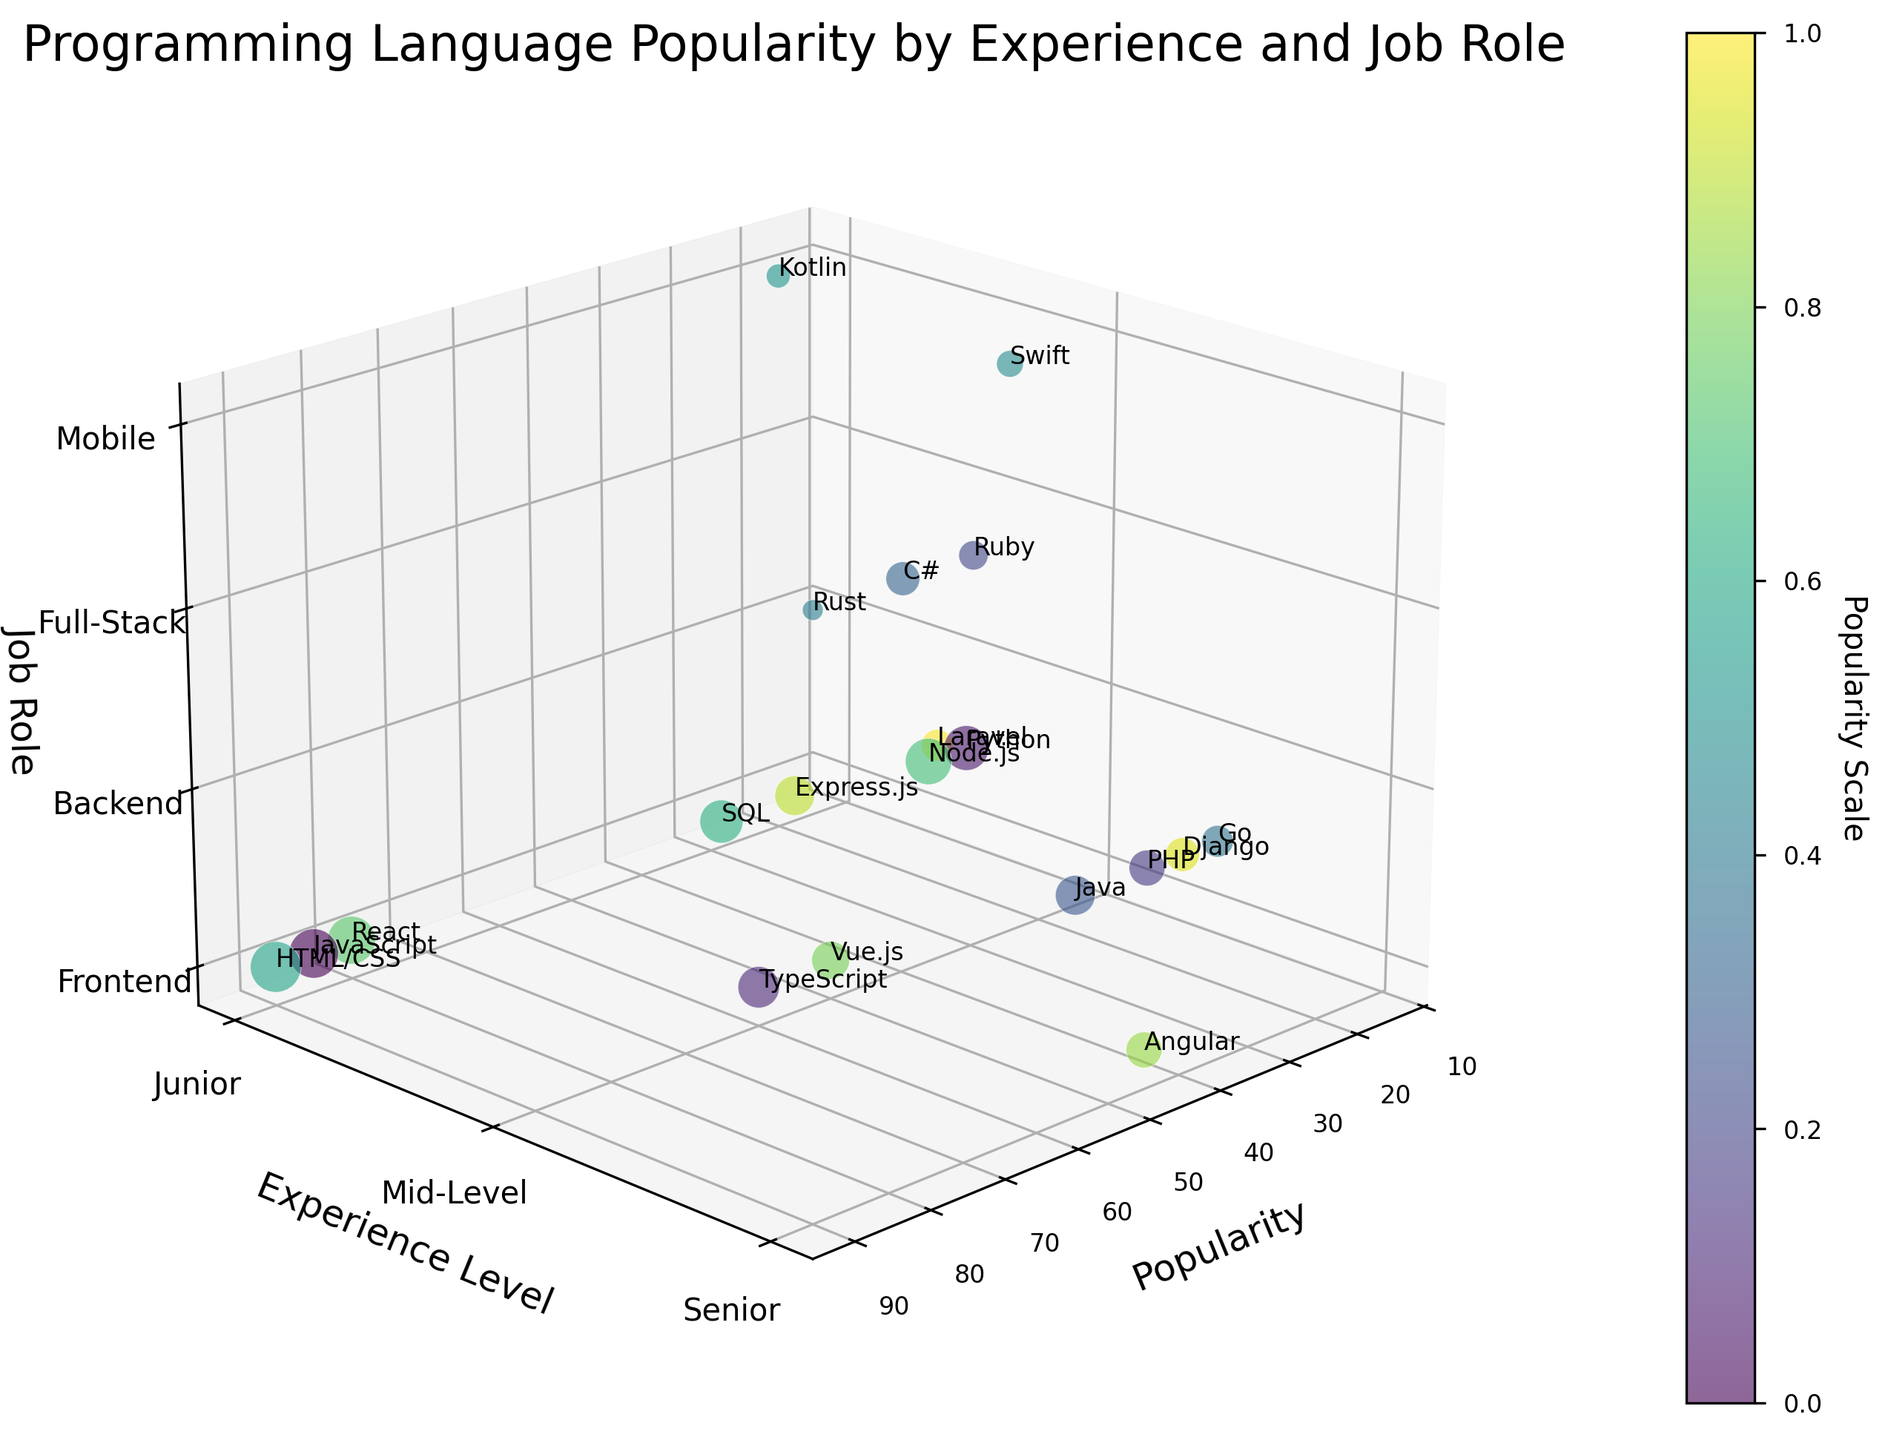What does the figure's title indicate? The figure's title provides a concise summary of the chart's content, showing that it depicts programming language popularity among web developers segmented by experience level and job role. It sets the context for interpreting the plotted data.
Answer: Programming Language Popularity by Experience and Job Role How are the experience levels represented along the y-axis? The y-axis uses labels to indicate three distinct experience levels: "Junior," "Mid-Level," and "Senior." These labels correspond to specific numerical values used in plotting the data on the y-axis.
Answer: Junior, Mid-Level, Senior Which job role has the highest popularity score, and for which language? Analyzing the z-axis for job roles and the x-axis for popularity scores, we see that Frontend developers using HTML/CSS have the highest popularity score. This is indicated by a bubble with a high value on the popularity axis.
Answer: Frontend, HTML/CSS What can you say about the popularity of JavaScript among Junior web developers? By locating the bubble for JavaScript in the 3D space, we observe it positioned at the Junior experience level and Frontend job role, with a popularity score of 85. This indicates JavaScript is very popular among Junior Frontend developers.
Answer: Very popular (85) Which programming languages are used by Mid-Level Mobile developers? Observing the z-axis for the Mobile job role and the y-axis for Mid-Level experience, we can identify Swift as the programming language represented by bubbles at this intersection.
Answer: Swift Compare the popularity of Python among Senior Full-Stack developers to that of Node.js among the same group. Which one is more popular? Both bubbles are located at Senior experience level and Full-Stack job role on the 3D chart. Python's bubble shows a popularity of 70, whereas Node.js' bubble displays a higher popularity of 75.
Answer: Node.js is more popular (75) Which programming language has the lowest popularity score, and in what context (experience level and job role)? The bubble positioned at the lowest value on the popularity axis corresponds to Rust, which is at the Junior level and Backend job role, indicating it's the least popular among studied languages.
Answer: Rust, Junior, Backend Identify the programming languages preferred by Senior Backend developers. By isolating the Senior experience level on the y-axis and Backend role on the z-axis, we find bubbles for PHP (45), Java (55), Go (35), and Django (40). These languages are preferred by Senior Backend developers.
Answer: PHP, Java, Go, Django What is the difference in popularity between React and Vue.js among Junior Frontend developers? Locate the bubbles for React and Vue.js within the context of Junior Frontend developers. React has a bubble positioned at 80 on the popularity axis, while Vue.js's bubble shows 50. Hence, the difference is 80 - 50 = 30.
Answer: 30 How many programming languages are represented in the plot? By counting the distinct bubbles spread across the plot labeled with different language names, we determine there are 20 unique programming languages visualized in the chart.
Answer: 20 